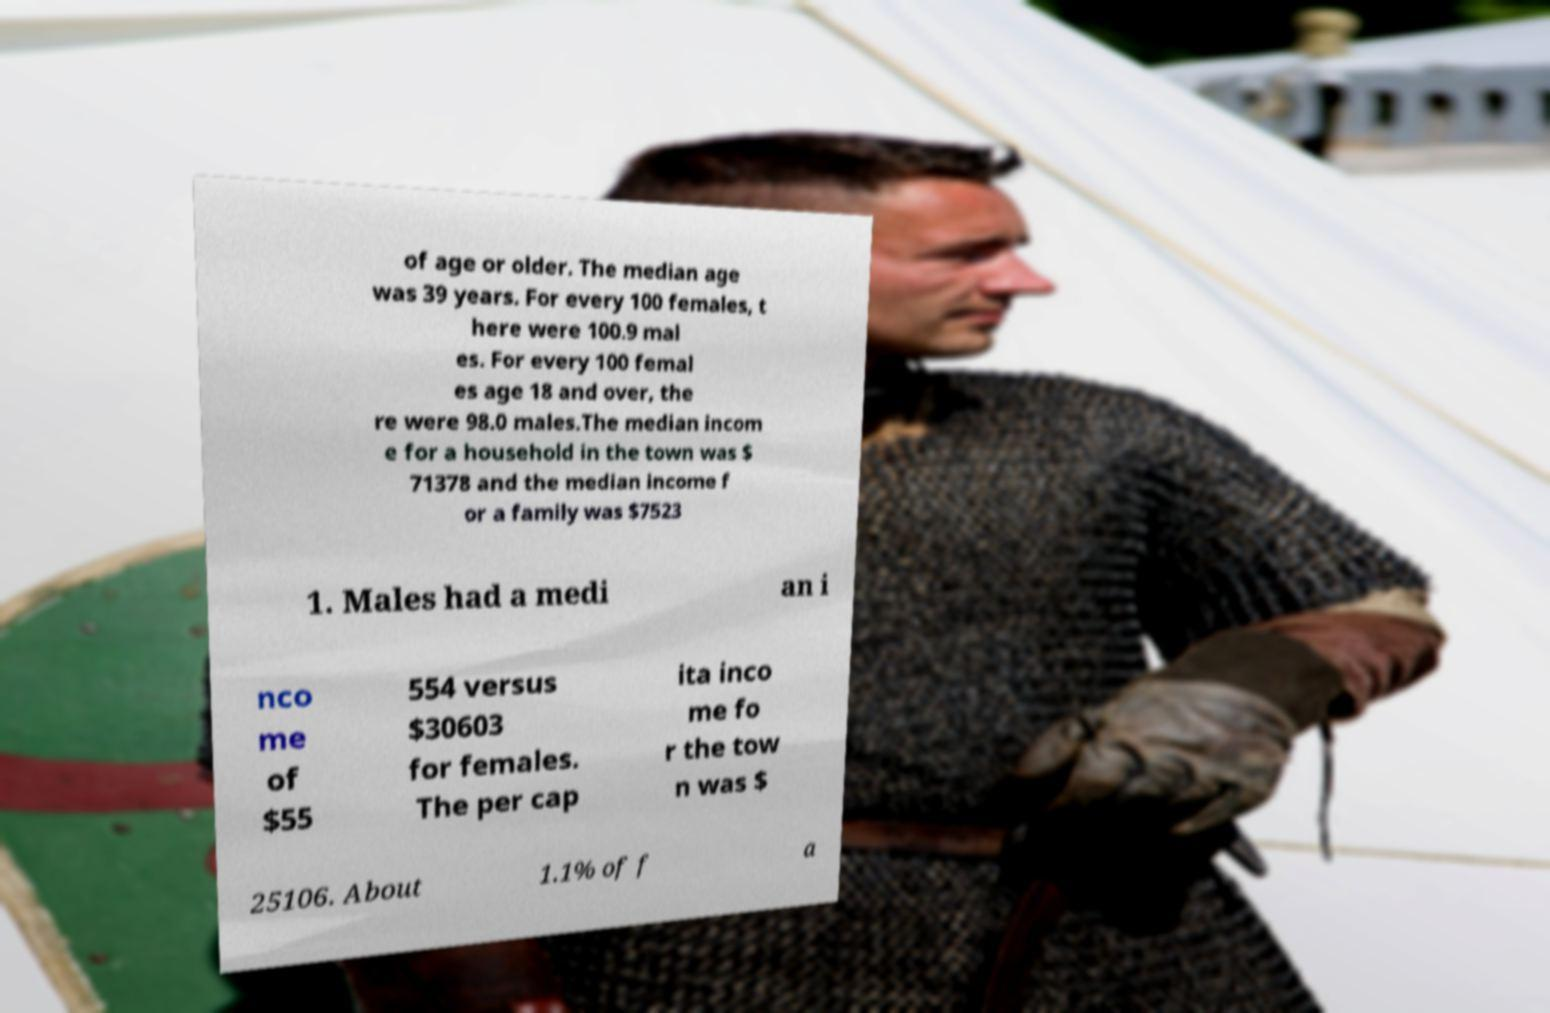For documentation purposes, I need the text within this image transcribed. Could you provide that? of age or older. The median age was 39 years. For every 100 females, t here were 100.9 mal es. For every 100 femal es age 18 and over, the re were 98.0 males.The median incom e for a household in the town was $ 71378 and the median income f or a family was $7523 1. Males had a medi an i nco me of $55 554 versus $30603 for females. The per cap ita inco me fo r the tow n was $ 25106. About 1.1% of f a 